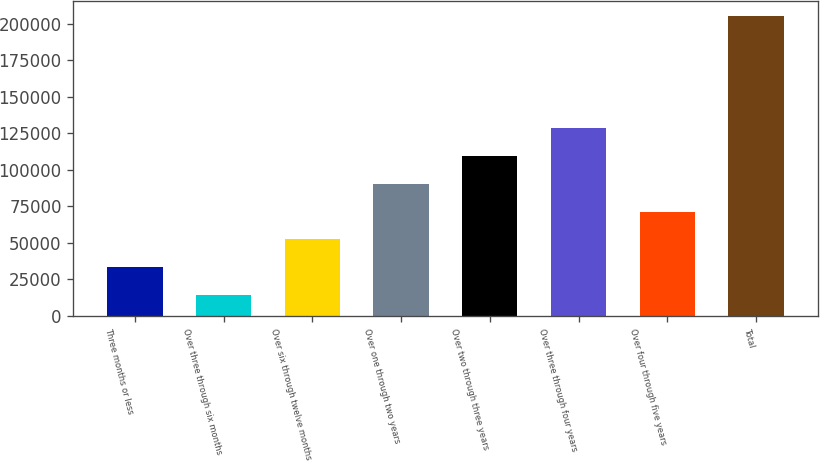Convert chart. <chart><loc_0><loc_0><loc_500><loc_500><bar_chart><fcel>Three months or less<fcel>Over three through six months<fcel>Over six through twelve months<fcel>Over one through two years<fcel>Over two through three years<fcel>Over three through four years<fcel>Over four through five years<fcel>Total<nl><fcel>33275.8<fcel>14191<fcel>52360.6<fcel>90530.2<fcel>109615<fcel>128700<fcel>71445.4<fcel>205039<nl></chart> 